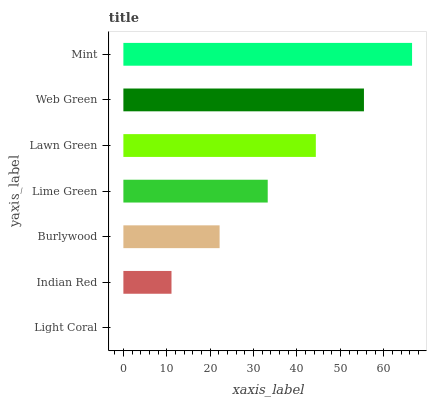Is Light Coral the minimum?
Answer yes or no. Yes. Is Mint the maximum?
Answer yes or no. Yes. Is Indian Red the minimum?
Answer yes or no. No. Is Indian Red the maximum?
Answer yes or no. No. Is Indian Red greater than Light Coral?
Answer yes or no. Yes. Is Light Coral less than Indian Red?
Answer yes or no. Yes. Is Light Coral greater than Indian Red?
Answer yes or no. No. Is Indian Red less than Light Coral?
Answer yes or no. No. Is Lime Green the high median?
Answer yes or no. Yes. Is Lime Green the low median?
Answer yes or no. Yes. Is Burlywood the high median?
Answer yes or no. No. Is Mint the low median?
Answer yes or no. No. 